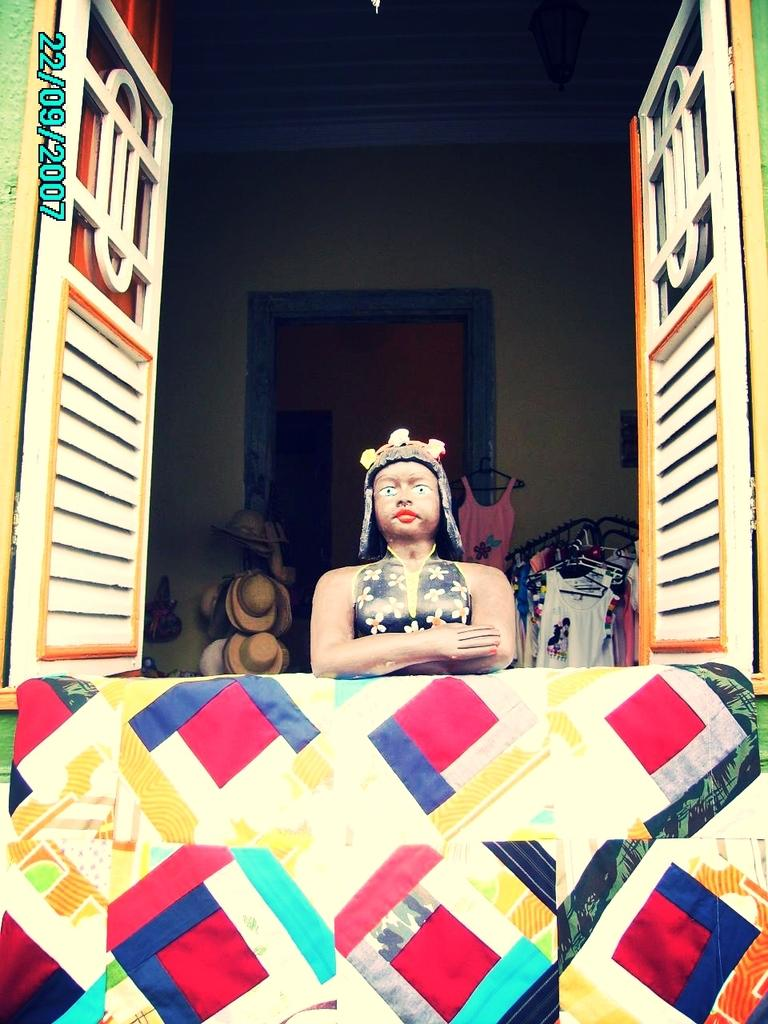What type of wall is depicted in the image? There is a colorful wall in the image. What is located behind the wall? There is a statue behind the wall. What architectural feature is present in the image? There is a window in the image. What types of items can be seen in the background? In the background, there are hats and clothes visible. What else can be seen in the background? In the background, there is another wall visible. What type of drug is being sold in the image? There is no indication of any drug being sold or present in the image. 